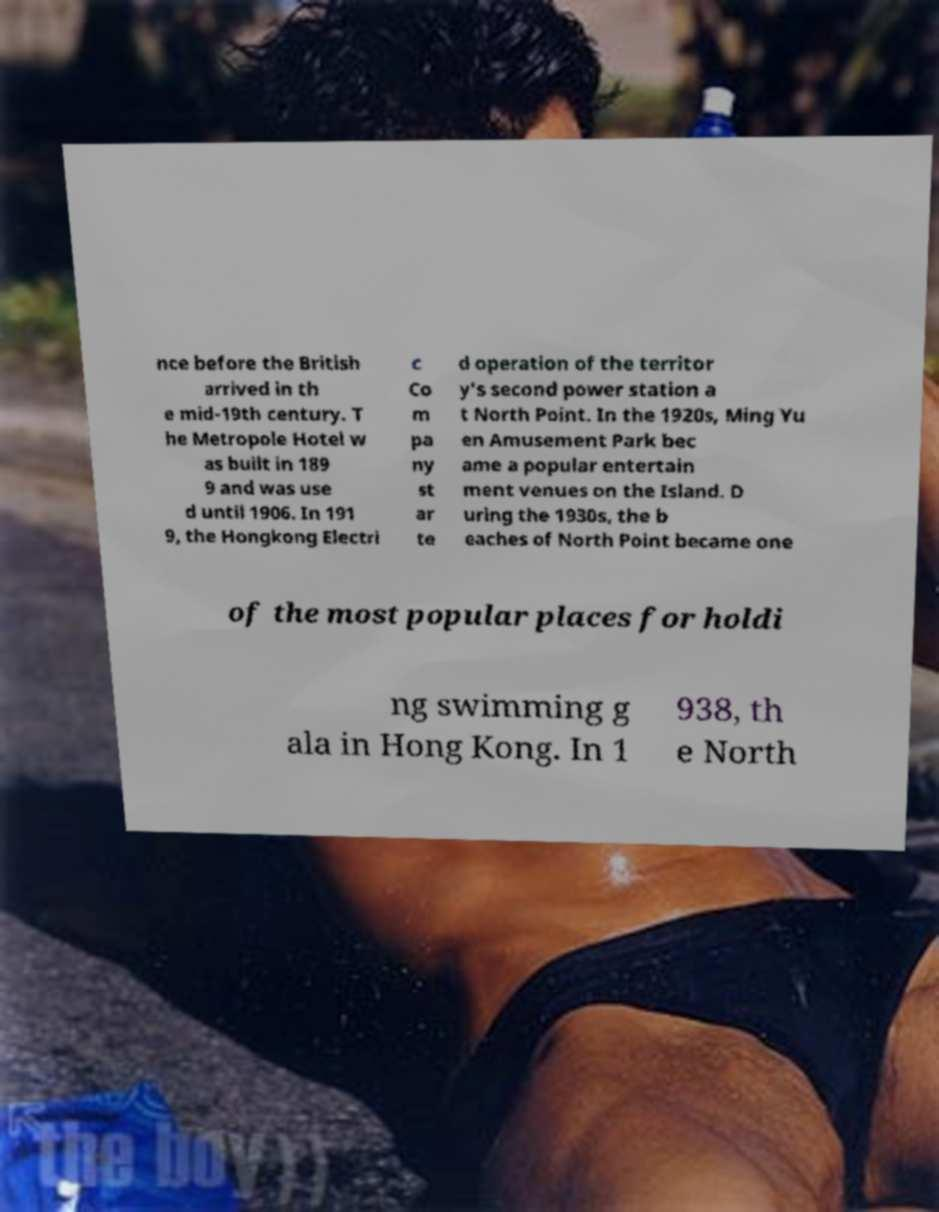Can you accurately transcribe the text from the provided image for me? nce before the British arrived in th e mid-19th century. T he Metropole Hotel w as built in 189 9 and was use d until 1906. In 191 9, the Hongkong Electri c Co m pa ny st ar te d operation of the territor y's second power station a t North Point. In the 1920s, Ming Yu en Amusement Park bec ame a popular entertain ment venues on the Island. D uring the 1930s, the b eaches of North Point became one of the most popular places for holdi ng swimming g ala in Hong Kong. In 1 938, th e North 